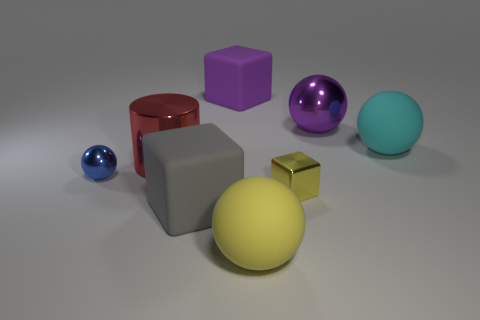Subtract 1 spheres. How many spheres are left? 3 Add 1 tiny brown spheres. How many objects exist? 9 Subtract all cubes. How many objects are left? 5 Add 2 cyan matte balls. How many cyan matte balls are left? 3 Add 7 large brown metal cylinders. How many large brown metal cylinders exist? 7 Subtract 0 green spheres. How many objects are left? 8 Subtract all tiny yellow rubber balls. Subtract all big yellow spheres. How many objects are left? 7 